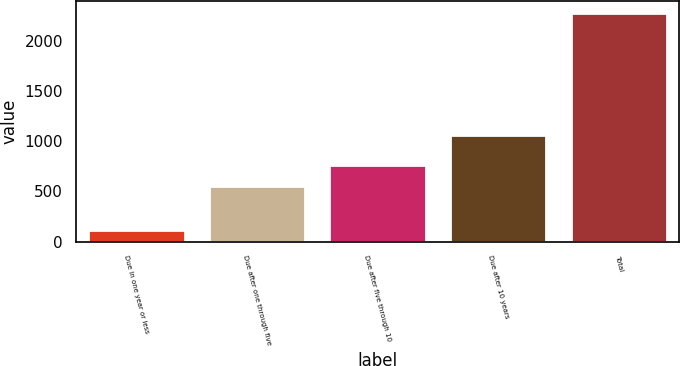Convert chart to OTSL. <chart><loc_0><loc_0><loc_500><loc_500><bar_chart><fcel>Due in one year or less<fcel>Due after one through five<fcel>Due after five through 10<fcel>Due after 10 years<fcel>Total<nl><fcel>117<fcel>552<fcel>768.7<fcel>1061<fcel>2284<nl></chart> 